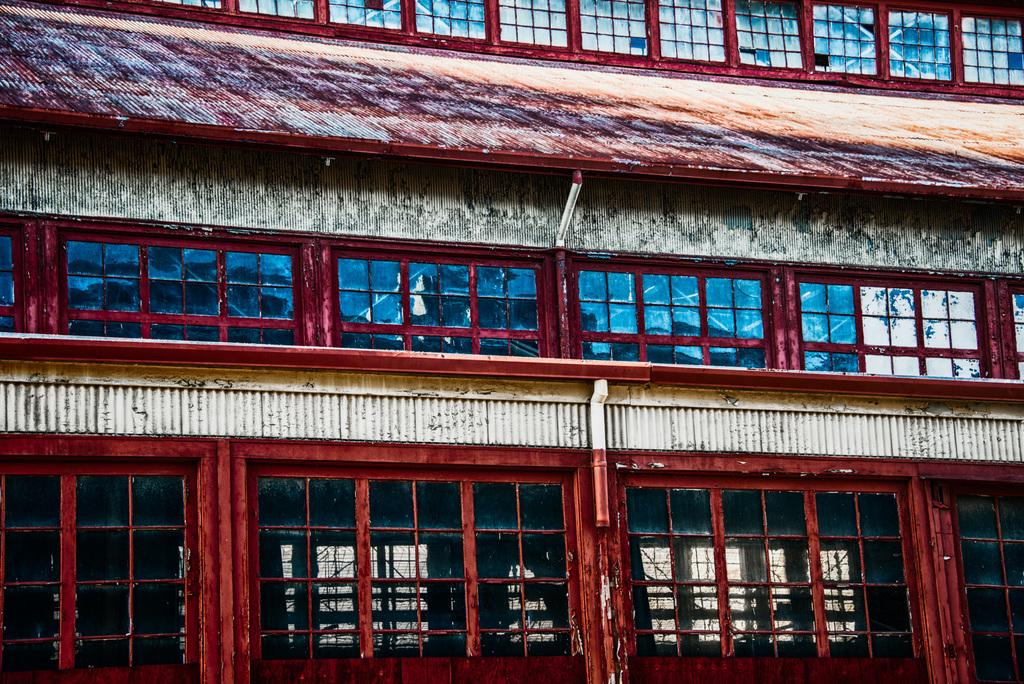What type of structure is visible in the image? There is a building in the image. How much of the building is visible in the image? Only a part of the building is captured in the image. What feature of the building is mentioned in the facts? The building has windows. What material are the windows made of? The windows have glass panels. What type of coastline can be seen near the building in the image? There is no coastline visible in the image; it only shows a part of the building. What property is being sold in the image? There is no property being sold in the image; it only shows a building with windows and glass panels. 